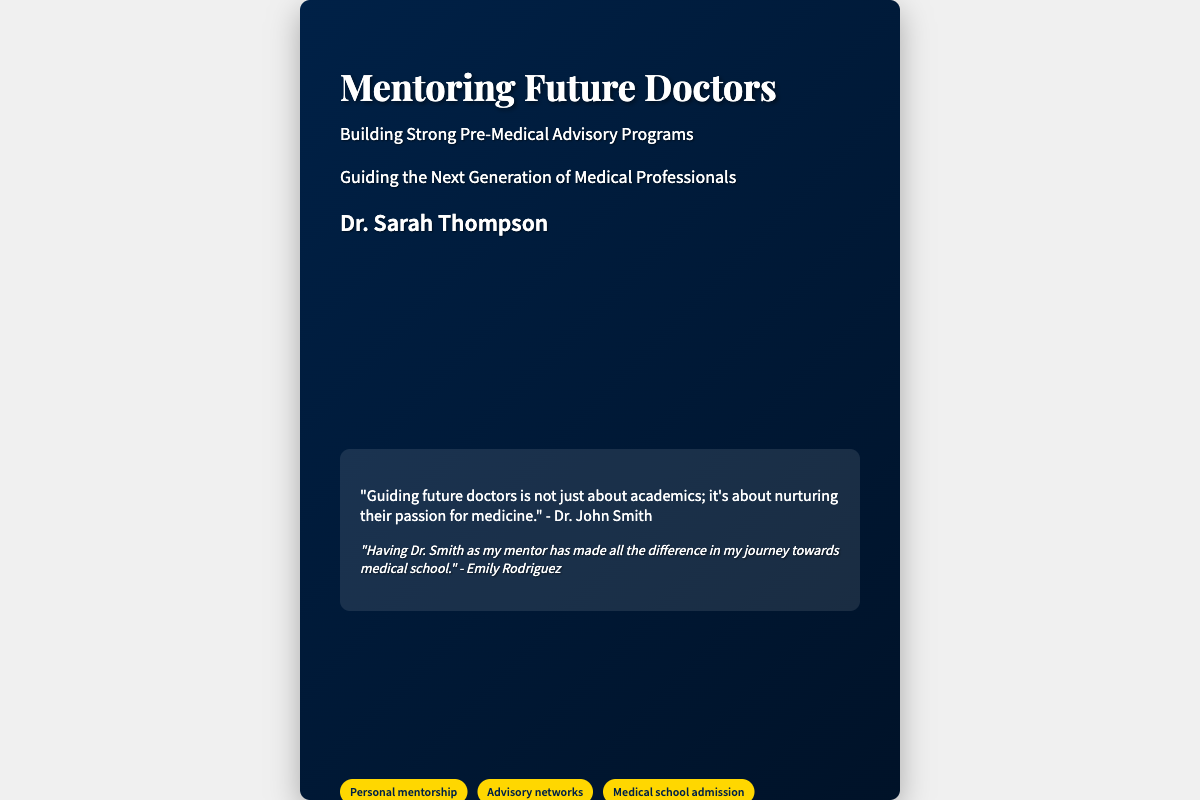What is the title of the book? The title of the book is prominently displayed on the cover.
Answer: Mentoring Future Doctors Who is the author of the book? The author's name is mentioned at the bottom of the cover.
Answer: Dr. Sarah Thompson What is the subtitle of the book? The subtitle provides additional context about the book's content.
Answer: Building Strong Pre-Medical Advisory Programs Which quote is attributed to Dr. John Smith? The quote reflects his views on mentoring future doctors.
Answer: "Guiding future doctors is not just about academics; it's about nurturing their passion for medicine." What color is the theme for 'Personal mentorship'? The background color of the themes section is specified.
Answer: #FFD700 (gold) How many themes are listed on the cover? The themes section shows a few different themes that are relevant to the content.
Answer: Four What is Emily Rodriguez's relationship with Dr. Smith? Emily's statement clearly indicates her relationship with Dr. Smith.
Answer: Mentor-mentee What is the backdrop of the book cover? The background image adds context to the setting of the book cover.
Answer: Bustling university campus 